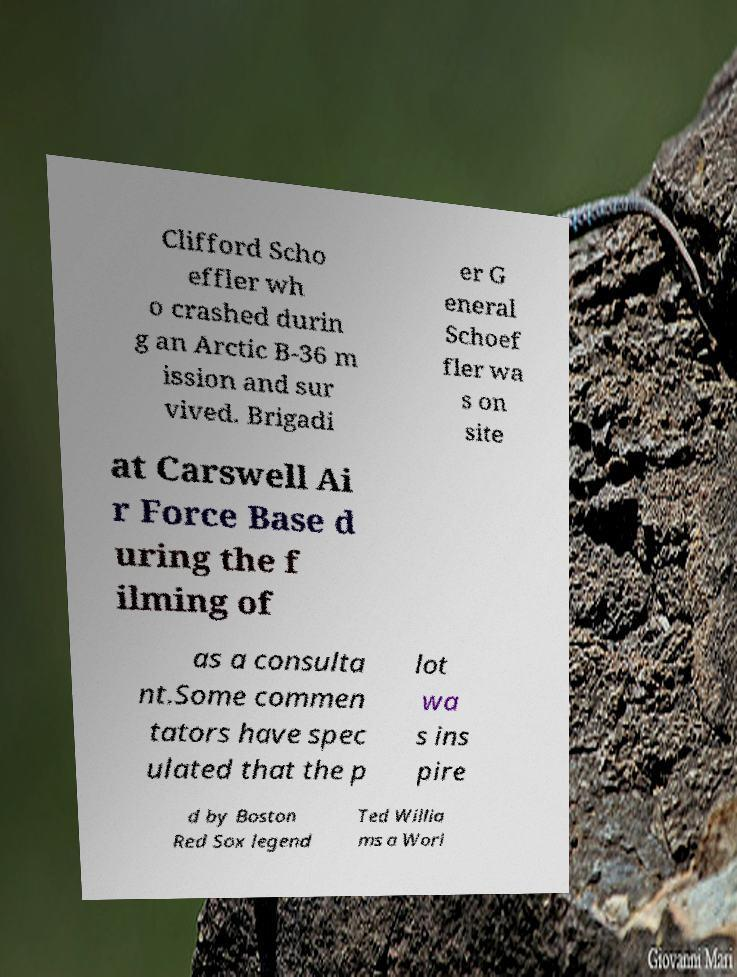For documentation purposes, I need the text within this image transcribed. Could you provide that? Clifford Scho effler wh o crashed durin g an Arctic B-36 m ission and sur vived. Brigadi er G eneral Schoef fler wa s on site at Carswell Ai r Force Base d uring the f ilming of as a consulta nt.Some commen tators have spec ulated that the p lot wa s ins pire d by Boston Red Sox legend Ted Willia ms a Worl 